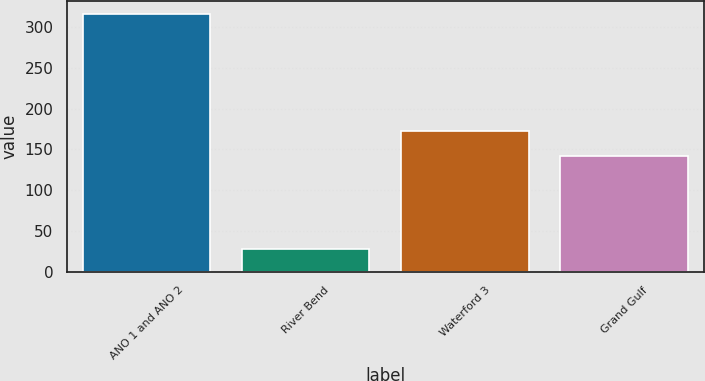Convert chart to OTSL. <chart><loc_0><loc_0><loc_500><loc_500><bar_chart><fcel>ANO 1 and ANO 2<fcel>River Bend<fcel>Waterford 3<fcel>Grand Gulf<nl><fcel>316.3<fcel>28.4<fcel>172.8<fcel>142.5<nl></chart> 